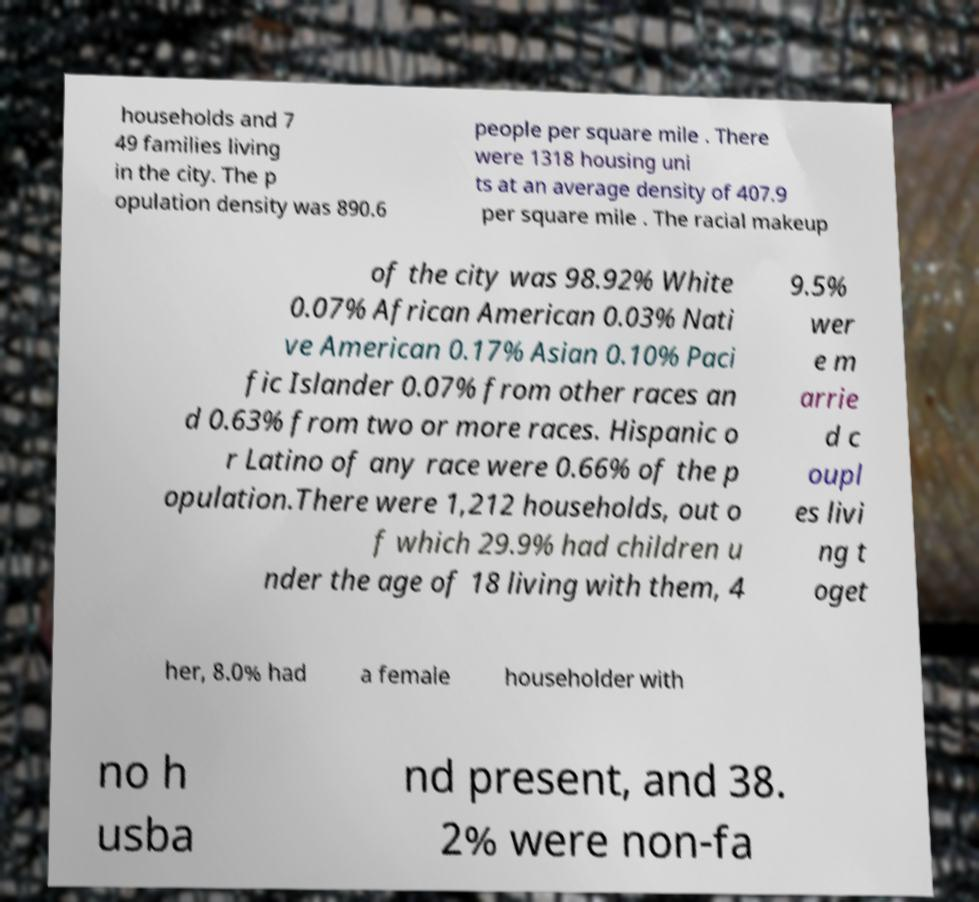For documentation purposes, I need the text within this image transcribed. Could you provide that? households and 7 49 families living in the city. The p opulation density was 890.6 people per square mile . There were 1318 housing uni ts at an average density of 407.9 per square mile . The racial makeup of the city was 98.92% White 0.07% African American 0.03% Nati ve American 0.17% Asian 0.10% Paci fic Islander 0.07% from other races an d 0.63% from two or more races. Hispanic o r Latino of any race were 0.66% of the p opulation.There were 1,212 households, out o f which 29.9% had children u nder the age of 18 living with them, 4 9.5% wer e m arrie d c oupl es livi ng t oget her, 8.0% had a female householder with no h usba nd present, and 38. 2% were non-fa 